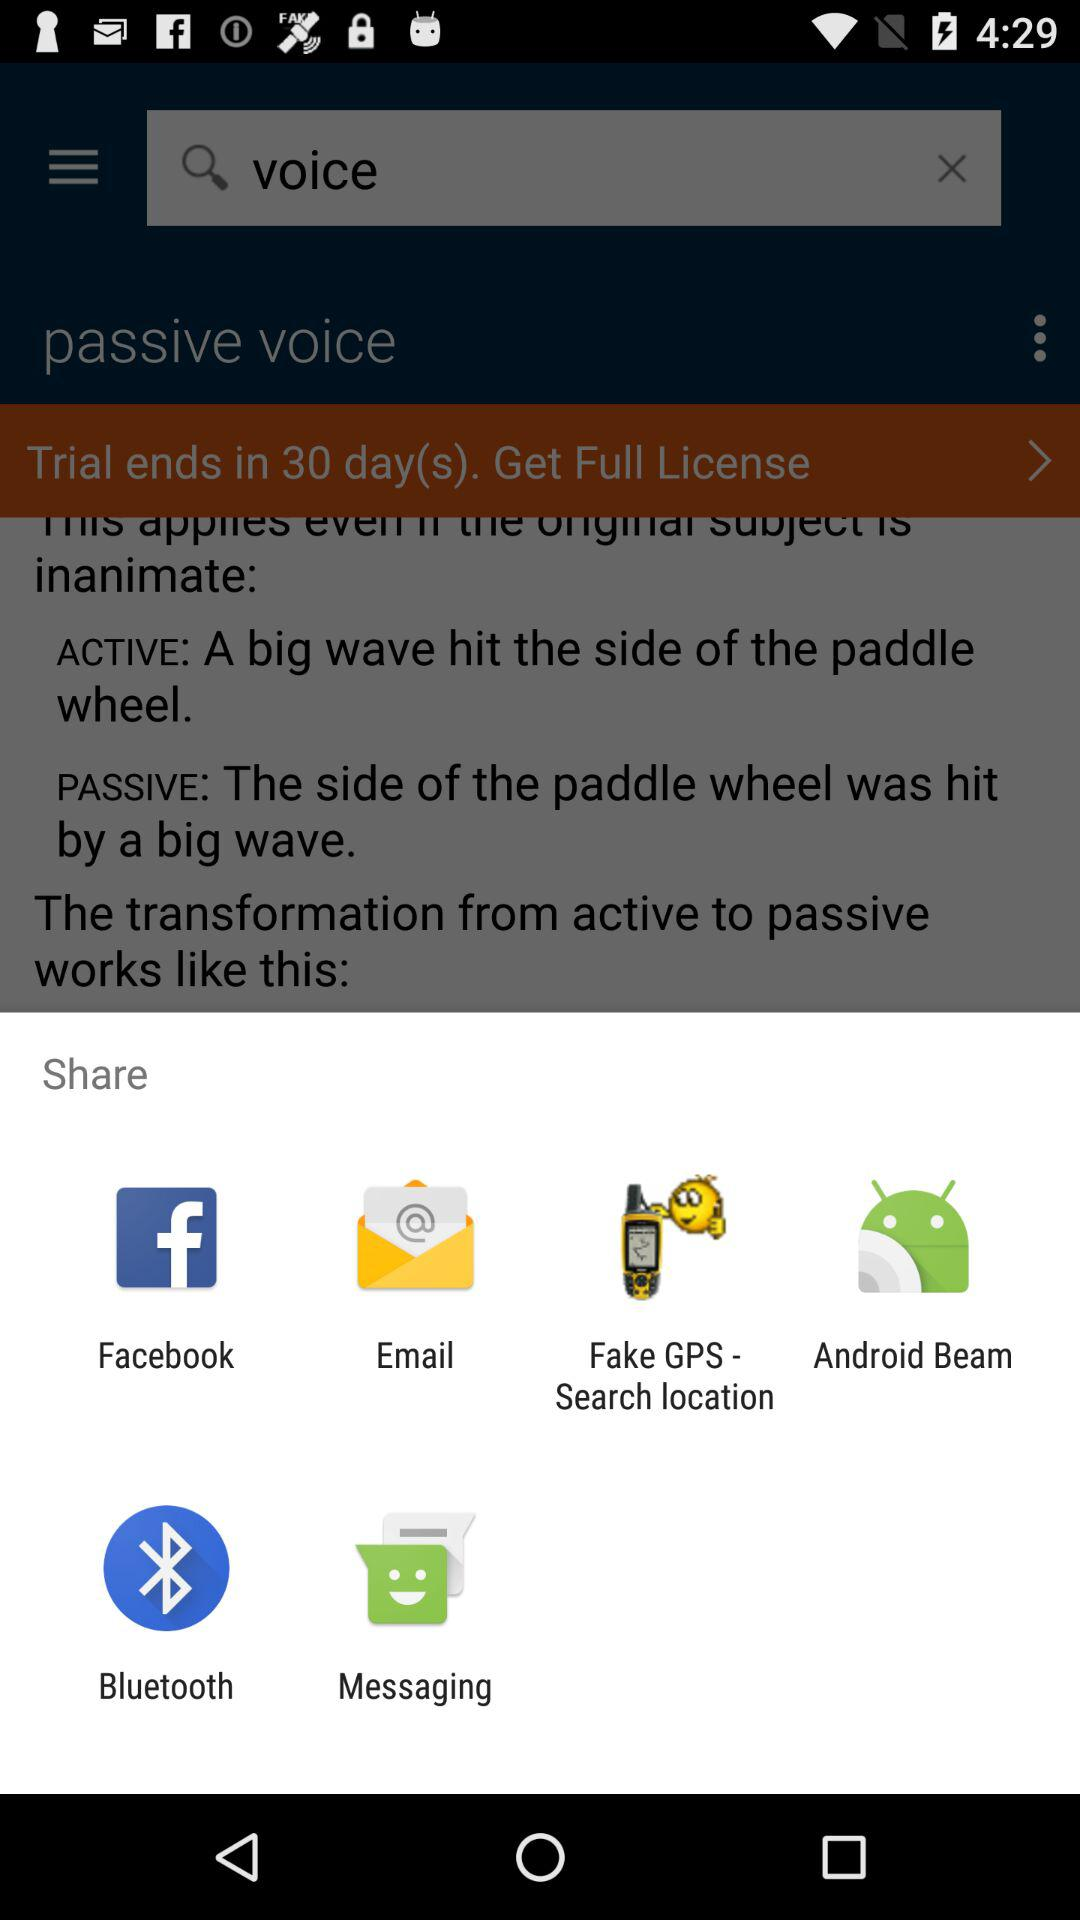How much is the full license?
When the provided information is insufficient, respond with <no answer>. <no answer> 